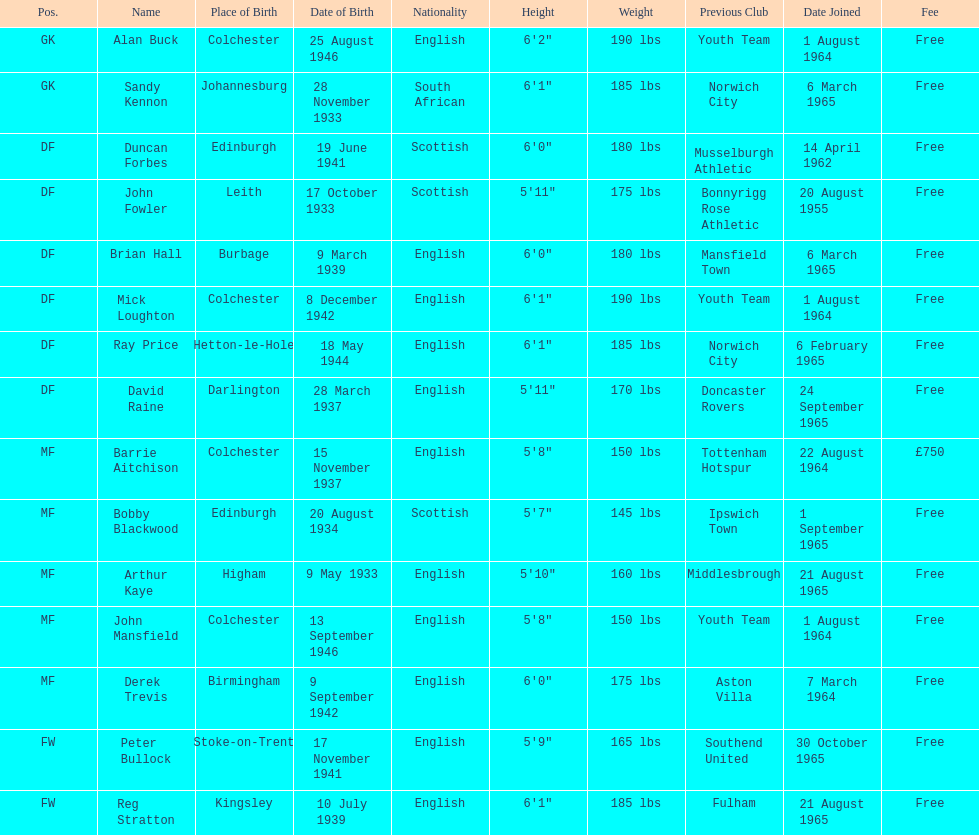How many players are listed as df? 6. 